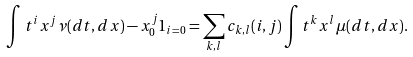<formula> <loc_0><loc_0><loc_500><loc_500>\int t ^ { i } x ^ { j } \nu ( d t , d x ) - x _ { 0 } ^ { j } 1 _ { i = 0 } = \sum _ { k , l } c _ { k , l } ( i , j ) \int t ^ { k } x ^ { l } \mu ( d t , d x ) .</formula> 